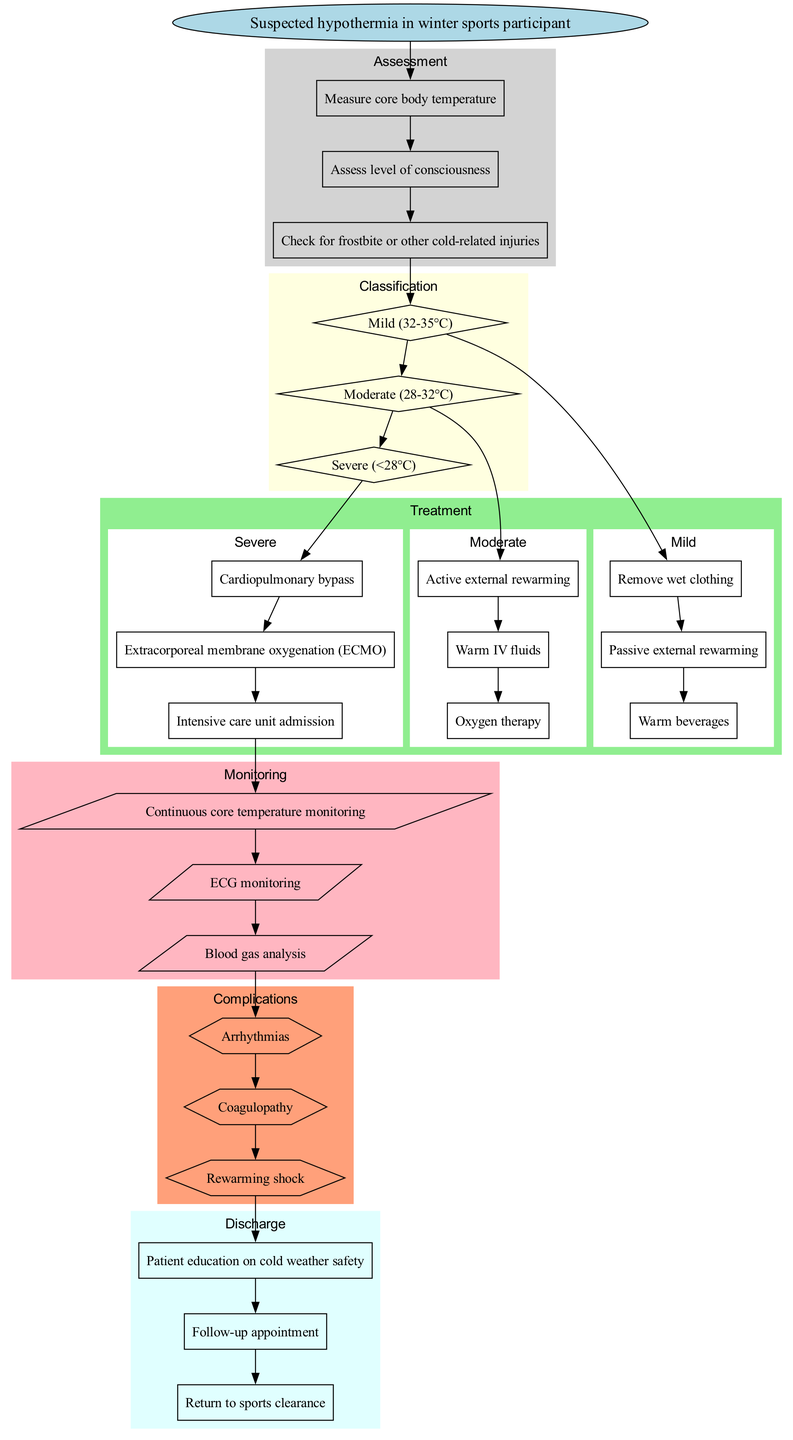What is the first step in managing suspected hypothermia? The diagram shows that the first step is to start with "Suspected hypothermia in winter sports participant." This is the initial node that begins the clinical pathway.
Answer: Suspected hypothermia in winter sports participant What are the three classifications of hypothermia listed? The three classifications of hypothermia in the diagram are represented as the diamond-shaped nodes. They are "Mild (32-35°C)", "Moderate (28-32°C)", and "Severe (<28°C)".
Answer: Mild (32-35°C), Moderate (28-32°C), Severe (<28°C) How many different treatments are indicated for severe hypothermia? For severe hypothermia, the diagram lists three specific treatments: "Cardiopulmonary bypass", "Extracorporeal membrane oxygenation (ECMO)", and "Intensive care unit admission". Counting these leads to the answer.
Answer: 3 What process follows the treatment for severe hypothermia? After the treatment for severe hypothermia, which denotes monitoring, the next step is indicated by the edge leading to "Continuous core temperature monitoring", followed by further monitoring steps. This indicates a shift from treatment to monitoring.
Answer: Continuous core temperature monitoring What is the last step in the discharge section? In the discharge section of the diagram, the last listed step is "Return to sports clearance". This indicates the completion of the clinical pathway leading to discharge.
Answer: Return to sports clearance How many complications are identified in the pathway? The diagram features three complications represented in hexagon-shaped nodes. They are "Arrhythmias", "Coagulopathy", and "Rewarming shock". This allows for counting the identified complications.
Answer: 3 Which assessment should be performed first? The diagram shows that the first assessment step is "Measure core body temperature". This establishes the initial assessment action taken for a participant suspected of hypothermia.
Answer: Measure core body temperature What type of monitoring is included after severe treatment? Following the treatment for severe hypothermia, monitoring includes "Continuous core temperature monitoring" as the first item, and this specific type of monitoring encapsulates the ongoing assessments performed thereafter.
Answer: Continuous core temperature monitoring 